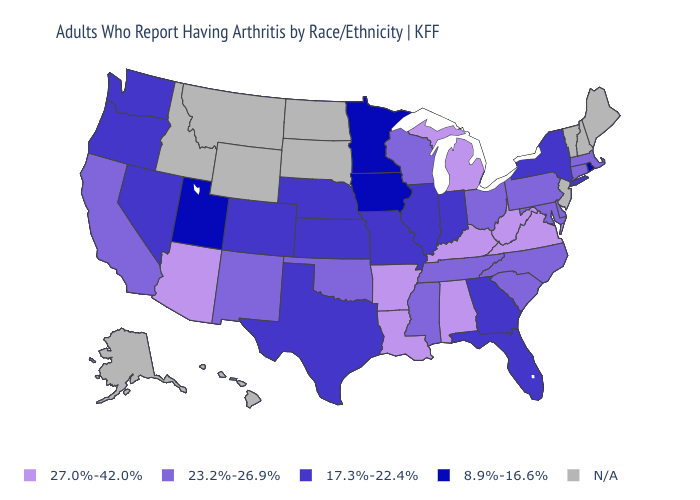What is the value of Wisconsin?
Concise answer only. 23.2%-26.9%. Does the map have missing data?
Write a very short answer. Yes. Does Arizona have the highest value in the USA?
Keep it brief. Yes. Which states have the highest value in the USA?
Keep it brief. Alabama, Arizona, Arkansas, Kentucky, Louisiana, Michigan, Virginia, West Virginia. Is the legend a continuous bar?
Write a very short answer. No. Name the states that have a value in the range 8.9%-16.6%?
Quick response, please. Iowa, Minnesota, Rhode Island, Utah. Which states have the lowest value in the USA?
Be succinct. Iowa, Minnesota, Rhode Island, Utah. Which states hav the highest value in the MidWest?
Short answer required. Michigan. Among the states that border North Dakota , which have the lowest value?
Keep it brief. Minnesota. What is the lowest value in states that border Illinois?
Give a very brief answer. 8.9%-16.6%. What is the value of Maine?
Write a very short answer. N/A. What is the lowest value in the USA?
Answer briefly. 8.9%-16.6%. Which states hav the highest value in the West?
Short answer required. Arizona. What is the lowest value in states that border Florida?
Concise answer only. 17.3%-22.4%. 